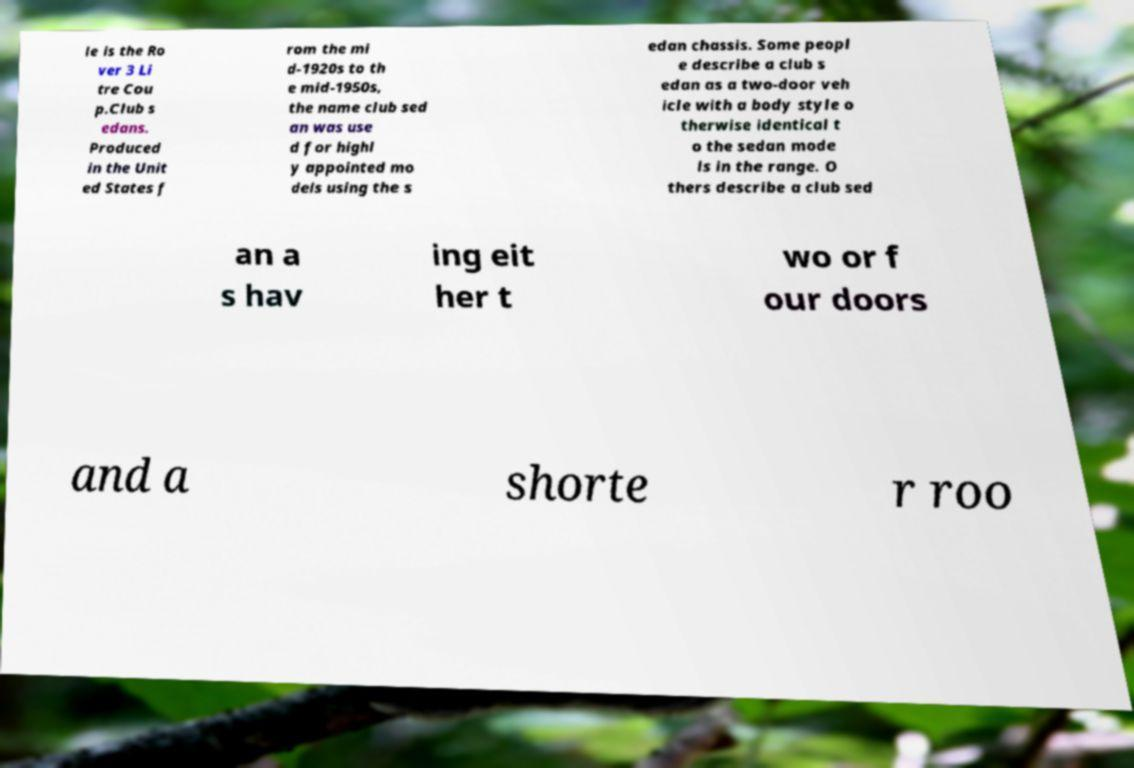There's text embedded in this image that I need extracted. Can you transcribe it verbatim? le is the Ro ver 3 Li tre Cou p.Club s edans. Produced in the Unit ed States f rom the mi d-1920s to th e mid-1950s, the name club sed an was use d for highl y appointed mo dels using the s edan chassis. Some peopl e describe a club s edan as a two-door veh icle with a body style o therwise identical t o the sedan mode ls in the range. O thers describe a club sed an a s hav ing eit her t wo or f our doors and a shorte r roo 